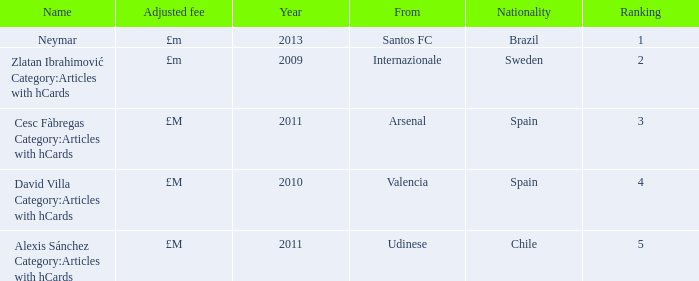What is the name of the player from Spain with a rank lower than 3? David Villa Category:Articles with hCards. Can you parse all the data within this table? {'header': ['Name', 'Adjusted fee', 'Year', 'From', 'Nationality', 'Ranking'], 'rows': [['Neymar', '£m', '2013', 'Santos FC', 'Brazil', '1'], ['Zlatan Ibrahimović Category:Articles with hCards', '£m', '2009', 'Internazionale', 'Sweden', '2'], ['Cesc Fàbregas Category:Articles with hCards', '£M', '2011', 'Arsenal', 'Spain', '3'], ['David Villa Category:Articles with hCards', '£M', '2010', 'Valencia', 'Spain', '4'], ['Alexis Sánchez Category:Articles with hCards', '£M', '2011', 'Udinese', 'Chile', '5']]} 